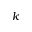Convert formula to latex. <formula><loc_0><loc_0><loc_500><loc_500>k</formula> 